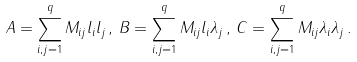Convert formula to latex. <formula><loc_0><loc_0><loc_500><loc_500>A = \sum _ { i , j = 1 } ^ { q } M _ { i j } l _ { i } l _ { j } \, , \, B = \sum _ { i , j = 1 } ^ { q } M _ { i j } l _ { i } \lambda _ { j } \, , \, C = \sum _ { i , j = 1 } ^ { q } M _ { i j } \lambda _ { i } \lambda _ { j } \, .</formula> 